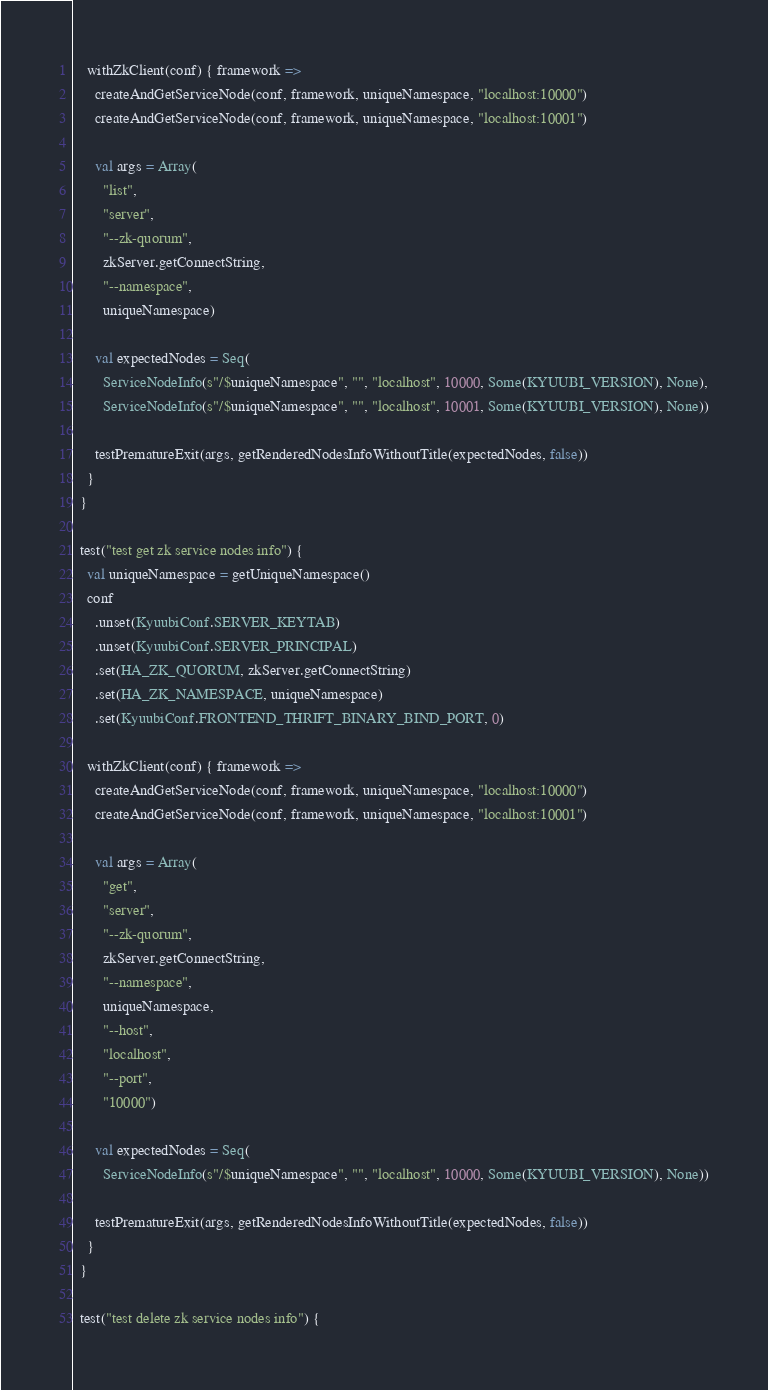<code> <loc_0><loc_0><loc_500><loc_500><_Scala_>
    withZkClient(conf) { framework =>
      createAndGetServiceNode(conf, framework, uniqueNamespace, "localhost:10000")
      createAndGetServiceNode(conf, framework, uniqueNamespace, "localhost:10001")

      val args = Array(
        "list",
        "server",
        "--zk-quorum",
        zkServer.getConnectString,
        "--namespace",
        uniqueNamespace)

      val expectedNodes = Seq(
        ServiceNodeInfo(s"/$uniqueNamespace", "", "localhost", 10000, Some(KYUUBI_VERSION), None),
        ServiceNodeInfo(s"/$uniqueNamespace", "", "localhost", 10001, Some(KYUUBI_VERSION), None))

      testPrematureExit(args, getRenderedNodesInfoWithoutTitle(expectedNodes, false))
    }
  }

  test("test get zk service nodes info") {
    val uniqueNamespace = getUniqueNamespace()
    conf
      .unset(KyuubiConf.SERVER_KEYTAB)
      .unset(KyuubiConf.SERVER_PRINCIPAL)
      .set(HA_ZK_QUORUM, zkServer.getConnectString)
      .set(HA_ZK_NAMESPACE, uniqueNamespace)
      .set(KyuubiConf.FRONTEND_THRIFT_BINARY_BIND_PORT, 0)

    withZkClient(conf) { framework =>
      createAndGetServiceNode(conf, framework, uniqueNamespace, "localhost:10000")
      createAndGetServiceNode(conf, framework, uniqueNamespace, "localhost:10001")

      val args = Array(
        "get",
        "server",
        "--zk-quorum",
        zkServer.getConnectString,
        "--namespace",
        uniqueNamespace,
        "--host",
        "localhost",
        "--port",
        "10000")

      val expectedNodes = Seq(
        ServiceNodeInfo(s"/$uniqueNamespace", "", "localhost", 10000, Some(KYUUBI_VERSION), None))

      testPrematureExit(args, getRenderedNodesInfoWithoutTitle(expectedNodes, false))
    }
  }

  test("test delete zk service nodes info") {</code> 